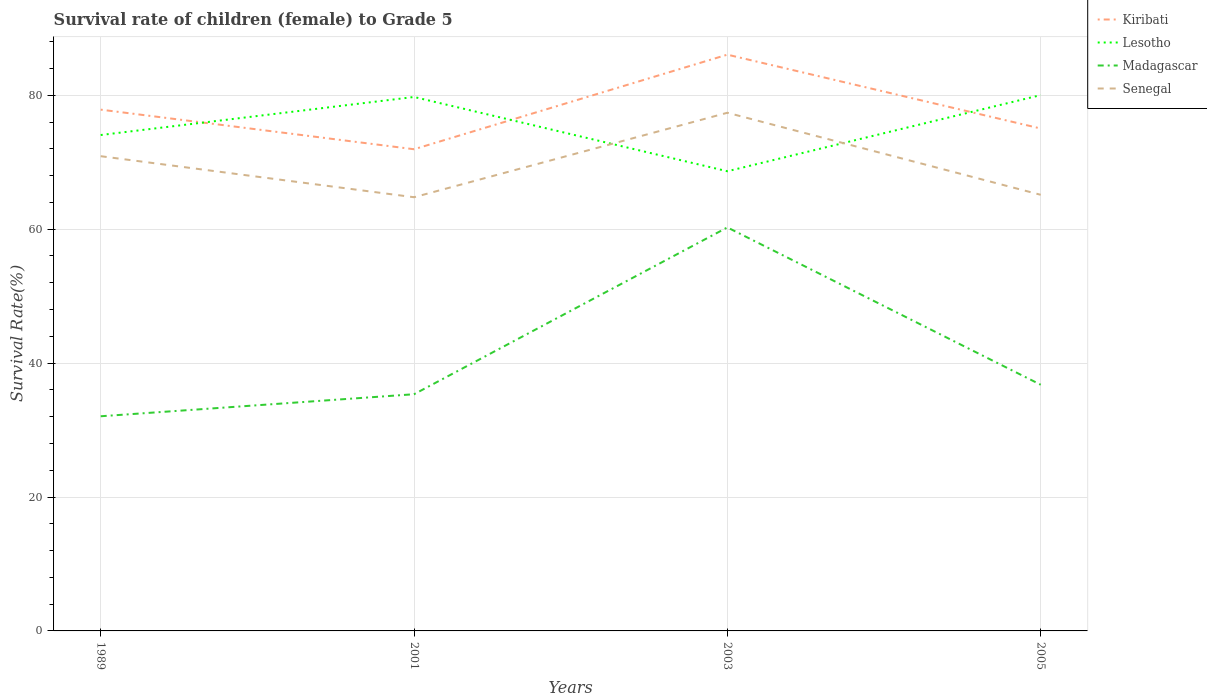Across all years, what is the maximum survival rate of female children to grade 5 in Kiribati?
Offer a very short reply. 71.94. What is the total survival rate of female children to grade 5 in Lesotho in the graph?
Your response must be concise. -0.28. What is the difference between the highest and the second highest survival rate of female children to grade 5 in Lesotho?
Ensure brevity in your answer.  11.37. How many years are there in the graph?
Provide a succinct answer. 4. What is the difference between two consecutive major ticks on the Y-axis?
Provide a short and direct response. 20. Are the values on the major ticks of Y-axis written in scientific E-notation?
Offer a terse response. No. Does the graph contain grids?
Provide a succinct answer. Yes. Where does the legend appear in the graph?
Offer a terse response. Top right. How many legend labels are there?
Your answer should be very brief. 4. What is the title of the graph?
Your response must be concise. Survival rate of children (female) to Grade 5. What is the label or title of the Y-axis?
Provide a short and direct response. Survival Rate(%). What is the Survival Rate(%) in Kiribati in 1989?
Provide a succinct answer. 77.85. What is the Survival Rate(%) of Lesotho in 1989?
Keep it short and to the point. 74.06. What is the Survival Rate(%) in Madagascar in 1989?
Your answer should be very brief. 32.06. What is the Survival Rate(%) of Senegal in 1989?
Offer a very short reply. 70.9. What is the Survival Rate(%) of Kiribati in 2001?
Provide a short and direct response. 71.94. What is the Survival Rate(%) of Lesotho in 2001?
Offer a very short reply. 79.74. What is the Survival Rate(%) of Madagascar in 2001?
Give a very brief answer. 35.35. What is the Survival Rate(%) of Senegal in 2001?
Ensure brevity in your answer.  64.77. What is the Survival Rate(%) of Kiribati in 2003?
Make the answer very short. 86.07. What is the Survival Rate(%) of Lesotho in 2003?
Your answer should be very brief. 68.65. What is the Survival Rate(%) in Madagascar in 2003?
Give a very brief answer. 60.26. What is the Survival Rate(%) in Senegal in 2003?
Provide a short and direct response. 77.39. What is the Survival Rate(%) of Kiribati in 2005?
Ensure brevity in your answer.  75.03. What is the Survival Rate(%) in Lesotho in 2005?
Give a very brief answer. 80.02. What is the Survival Rate(%) of Madagascar in 2005?
Your answer should be compact. 36.77. What is the Survival Rate(%) of Senegal in 2005?
Offer a very short reply. 65.13. Across all years, what is the maximum Survival Rate(%) of Kiribati?
Your answer should be compact. 86.07. Across all years, what is the maximum Survival Rate(%) of Lesotho?
Offer a very short reply. 80.02. Across all years, what is the maximum Survival Rate(%) of Madagascar?
Offer a terse response. 60.26. Across all years, what is the maximum Survival Rate(%) in Senegal?
Make the answer very short. 77.39. Across all years, what is the minimum Survival Rate(%) in Kiribati?
Your answer should be compact. 71.94. Across all years, what is the minimum Survival Rate(%) in Lesotho?
Ensure brevity in your answer.  68.65. Across all years, what is the minimum Survival Rate(%) of Madagascar?
Give a very brief answer. 32.06. Across all years, what is the minimum Survival Rate(%) in Senegal?
Your answer should be very brief. 64.77. What is the total Survival Rate(%) in Kiribati in the graph?
Your answer should be very brief. 310.89. What is the total Survival Rate(%) of Lesotho in the graph?
Make the answer very short. 302.48. What is the total Survival Rate(%) of Madagascar in the graph?
Ensure brevity in your answer.  164.44. What is the total Survival Rate(%) in Senegal in the graph?
Ensure brevity in your answer.  278.19. What is the difference between the Survival Rate(%) of Kiribati in 1989 and that in 2001?
Your answer should be compact. 5.91. What is the difference between the Survival Rate(%) of Lesotho in 1989 and that in 2001?
Make the answer very short. -5.68. What is the difference between the Survival Rate(%) of Madagascar in 1989 and that in 2001?
Offer a very short reply. -3.29. What is the difference between the Survival Rate(%) in Senegal in 1989 and that in 2001?
Your response must be concise. 6.13. What is the difference between the Survival Rate(%) in Kiribati in 1989 and that in 2003?
Your answer should be compact. -8.21. What is the difference between the Survival Rate(%) of Lesotho in 1989 and that in 2003?
Keep it short and to the point. 5.41. What is the difference between the Survival Rate(%) in Madagascar in 1989 and that in 2003?
Your answer should be compact. -28.2. What is the difference between the Survival Rate(%) in Senegal in 1989 and that in 2003?
Your answer should be compact. -6.49. What is the difference between the Survival Rate(%) of Kiribati in 1989 and that in 2005?
Offer a terse response. 2.82. What is the difference between the Survival Rate(%) of Lesotho in 1989 and that in 2005?
Give a very brief answer. -5.96. What is the difference between the Survival Rate(%) in Madagascar in 1989 and that in 2005?
Keep it short and to the point. -4.71. What is the difference between the Survival Rate(%) of Senegal in 1989 and that in 2005?
Ensure brevity in your answer.  5.77. What is the difference between the Survival Rate(%) in Kiribati in 2001 and that in 2003?
Ensure brevity in your answer.  -14.13. What is the difference between the Survival Rate(%) of Lesotho in 2001 and that in 2003?
Keep it short and to the point. 11.09. What is the difference between the Survival Rate(%) of Madagascar in 2001 and that in 2003?
Ensure brevity in your answer.  -24.91. What is the difference between the Survival Rate(%) in Senegal in 2001 and that in 2003?
Offer a terse response. -12.62. What is the difference between the Survival Rate(%) of Kiribati in 2001 and that in 2005?
Offer a terse response. -3.1. What is the difference between the Survival Rate(%) in Lesotho in 2001 and that in 2005?
Keep it short and to the point. -0.28. What is the difference between the Survival Rate(%) in Madagascar in 2001 and that in 2005?
Provide a short and direct response. -1.42. What is the difference between the Survival Rate(%) of Senegal in 2001 and that in 2005?
Your response must be concise. -0.36. What is the difference between the Survival Rate(%) of Kiribati in 2003 and that in 2005?
Ensure brevity in your answer.  11.03. What is the difference between the Survival Rate(%) in Lesotho in 2003 and that in 2005?
Make the answer very short. -11.37. What is the difference between the Survival Rate(%) in Madagascar in 2003 and that in 2005?
Keep it short and to the point. 23.5. What is the difference between the Survival Rate(%) in Senegal in 2003 and that in 2005?
Provide a short and direct response. 12.25. What is the difference between the Survival Rate(%) in Kiribati in 1989 and the Survival Rate(%) in Lesotho in 2001?
Your answer should be compact. -1.89. What is the difference between the Survival Rate(%) in Kiribati in 1989 and the Survival Rate(%) in Madagascar in 2001?
Provide a short and direct response. 42.5. What is the difference between the Survival Rate(%) in Kiribati in 1989 and the Survival Rate(%) in Senegal in 2001?
Give a very brief answer. 13.08. What is the difference between the Survival Rate(%) of Lesotho in 1989 and the Survival Rate(%) of Madagascar in 2001?
Provide a short and direct response. 38.71. What is the difference between the Survival Rate(%) of Lesotho in 1989 and the Survival Rate(%) of Senegal in 2001?
Offer a terse response. 9.29. What is the difference between the Survival Rate(%) in Madagascar in 1989 and the Survival Rate(%) in Senegal in 2001?
Your answer should be compact. -32.71. What is the difference between the Survival Rate(%) in Kiribati in 1989 and the Survival Rate(%) in Lesotho in 2003?
Your answer should be compact. 9.2. What is the difference between the Survival Rate(%) of Kiribati in 1989 and the Survival Rate(%) of Madagascar in 2003?
Your response must be concise. 17.59. What is the difference between the Survival Rate(%) of Kiribati in 1989 and the Survival Rate(%) of Senegal in 2003?
Offer a terse response. 0.46. What is the difference between the Survival Rate(%) of Lesotho in 1989 and the Survival Rate(%) of Madagascar in 2003?
Provide a succinct answer. 13.8. What is the difference between the Survival Rate(%) of Lesotho in 1989 and the Survival Rate(%) of Senegal in 2003?
Give a very brief answer. -3.33. What is the difference between the Survival Rate(%) in Madagascar in 1989 and the Survival Rate(%) in Senegal in 2003?
Provide a short and direct response. -45.33. What is the difference between the Survival Rate(%) in Kiribati in 1989 and the Survival Rate(%) in Lesotho in 2005?
Your answer should be very brief. -2.17. What is the difference between the Survival Rate(%) in Kiribati in 1989 and the Survival Rate(%) in Madagascar in 2005?
Make the answer very short. 41.09. What is the difference between the Survival Rate(%) of Kiribati in 1989 and the Survival Rate(%) of Senegal in 2005?
Provide a succinct answer. 12.72. What is the difference between the Survival Rate(%) in Lesotho in 1989 and the Survival Rate(%) in Madagascar in 2005?
Offer a terse response. 37.3. What is the difference between the Survival Rate(%) of Lesotho in 1989 and the Survival Rate(%) of Senegal in 2005?
Your answer should be compact. 8.93. What is the difference between the Survival Rate(%) of Madagascar in 1989 and the Survival Rate(%) of Senegal in 2005?
Keep it short and to the point. -33.07. What is the difference between the Survival Rate(%) in Kiribati in 2001 and the Survival Rate(%) in Lesotho in 2003?
Offer a very short reply. 3.29. What is the difference between the Survival Rate(%) of Kiribati in 2001 and the Survival Rate(%) of Madagascar in 2003?
Provide a succinct answer. 11.68. What is the difference between the Survival Rate(%) in Kiribati in 2001 and the Survival Rate(%) in Senegal in 2003?
Provide a succinct answer. -5.45. What is the difference between the Survival Rate(%) in Lesotho in 2001 and the Survival Rate(%) in Madagascar in 2003?
Offer a terse response. 19.48. What is the difference between the Survival Rate(%) in Lesotho in 2001 and the Survival Rate(%) in Senegal in 2003?
Your answer should be very brief. 2.36. What is the difference between the Survival Rate(%) in Madagascar in 2001 and the Survival Rate(%) in Senegal in 2003?
Your response must be concise. -42.04. What is the difference between the Survival Rate(%) of Kiribati in 2001 and the Survival Rate(%) of Lesotho in 2005?
Your answer should be compact. -8.08. What is the difference between the Survival Rate(%) of Kiribati in 2001 and the Survival Rate(%) of Madagascar in 2005?
Make the answer very short. 35.17. What is the difference between the Survival Rate(%) in Kiribati in 2001 and the Survival Rate(%) in Senegal in 2005?
Your response must be concise. 6.8. What is the difference between the Survival Rate(%) in Lesotho in 2001 and the Survival Rate(%) in Madagascar in 2005?
Give a very brief answer. 42.98. What is the difference between the Survival Rate(%) in Lesotho in 2001 and the Survival Rate(%) in Senegal in 2005?
Your answer should be very brief. 14.61. What is the difference between the Survival Rate(%) in Madagascar in 2001 and the Survival Rate(%) in Senegal in 2005?
Give a very brief answer. -29.79. What is the difference between the Survival Rate(%) in Kiribati in 2003 and the Survival Rate(%) in Lesotho in 2005?
Provide a succinct answer. 6.04. What is the difference between the Survival Rate(%) of Kiribati in 2003 and the Survival Rate(%) of Madagascar in 2005?
Ensure brevity in your answer.  49.3. What is the difference between the Survival Rate(%) of Kiribati in 2003 and the Survival Rate(%) of Senegal in 2005?
Ensure brevity in your answer.  20.93. What is the difference between the Survival Rate(%) of Lesotho in 2003 and the Survival Rate(%) of Madagascar in 2005?
Your answer should be compact. 31.89. What is the difference between the Survival Rate(%) of Lesotho in 2003 and the Survival Rate(%) of Senegal in 2005?
Give a very brief answer. 3.52. What is the difference between the Survival Rate(%) of Madagascar in 2003 and the Survival Rate(%) of Senegal in 2005?
Ensure brevity in your answer.  -4.87. What is the average Survival Rate(%) in Kiribati per year?
Provide a short and direct response. 77.72. What is the average Survival Rate(%) in Lesotho per year?
Ensure brevity in your answer.  75.62. What is the average Survival Rate(%) of Madagascar per year?
Your answer should be very brief. 41.11. What is the average Survival Rate(%) of Senegal per year?
Keep it short and to the point. 69.55. In the year 1989, what is the difference between the Survival Rate(%) of Kiribati and Survival Rate(%) of Lesotho?
Give a very brief answer. 3.79. In the year 1989, what is the difference between the Survival Rate(%) in Kiribati and Survival Rate(%) in Madagascar?
Your response must be concise. 45.79. In the year 1989, what is the difference between the Survival Rate(%) in Kiribati and Survival Rate(%) in Senegal?
Keep it short and to the point. 6.95. In the year 1989, what is the difference between the Survival Rate(%) in Lesotho and Survival Rate(%) in Madagascar?
Ensure brevity in your answer.  42. In the year 1989, what is the difference between the Survival Rate(%) of Lesotho and Survival Rate(%) of Senegal?
Provide a succinct answer. 3.16. In the year 1989, what is the difference between the Survival Rate(%) of Madagascar and Survival Rate(%) of Senegal?
Provide a succinct answer. -38.84. In the year 2001, what is the difference between the Survival Rate(%) of Kiribati and Survival Rate(%) of Lesotho?
Your response must be concise. -7.8. In the year 2001, what is the difference between the Survival Rate(%) of Kiribati and Survival Rate(%) of Madagascar?
Provide a short and direct response. 36.59. In the year 2001, what is the difference between the Survival Rate(%) in Kiribati and Survival Rate(%) in Senegal?
Give a very brief answer. 7.17. In the year 2001, what is the difference between the Survival Rate(%) in Lesotho and Survival Rate(%) in Madagascar?
Provide a short and direct response. 44.39. In the year 2001, what is the difference between the Survival Rate(%) in Lesotho and Survival Rate(%) in Senegal?
Make the answer very short. 14.97. In the year 2001, what is the difference between the Survival Rate(%) of Madagascar and Survival Rate(%) of Senegal?
Provide a succinct answer. -29.42. In the year 2003, what is the difference between the Survival Rate(%) of Kiribati and Survival Rate(%) of Lesotho?
Provide a succinct answer. 17.41. In the year 2003, what is the difference between the Survival Rate(%) in Kiribati and Survival Rate(%) in Madagascar?
Give a very brief answer. 25.8. In the year 2003, what is the difference between the Survival Rate(%) in Kiribati and Survival Rate(%) in Senegal?
Your response must be concise. 8.68. In the year 2003, what is the difference between the Survival Rate(%) in Lesotho and Survival Rate(%) in Madagascar?
Provide a short and direct response. 8.39. In the year 2003, what is the difference between the Survival Rate(%) of Lesotho and Survival Rate(%) of Senegal?
Offer a terse response. -8.74. In the year 2003, what is the difference between the Survival Rate(%) of Madagascar and Survival Rate(%) of Senegal?
Provide a short and direct response. -17.12. In the year 2005, what is the difference between the Survival Rate(%) of Kiribati and Survival Rate(%) of Lesotho?
Offer a terse response. -4.99. In the year 2005, what is the difference between the Survival Rate(%) of Kiribati and Survival Rate(%) of Madagascar?
Keep it short and to the point. 38.27. In the year 2005, what is the difference between the Survival Rate(%) in Kiribati and Survival Rate(%) in Senegal?
Provide a short and direct response. 9.9. In the year 2005, what is the difference between the Survival Rate(%) in Lesotho and Survival Rate(%) in Madagascar?
Your answer should be compact. 43.26. In the year 2005, what is the difference between the Survival Rate(%) in Lesotho and Survival Rate(%) in Senegal?
Provide a succinct answer. 14.89. In the year 2005, what is the difference between the Survival Rate(%) in Madagascar and Survival Rate(%) in Senegal?
Your response must be concise. -28.37. What is the ratio of the Survival Rate(%) of Kiribati in 1989 to that in 2001?
Provide a succinct answer. 1.08. What is the ratio of the Survival Rate(%) of Lesotho in 1989 to that in 2001?
Offer a very short reply. 0.93. What is the ratio of the Survival Rate(%) of Madagascar in 1989 to that in 2001?
Give a very brief answer. 0.91. What is the ratio of the Survival Rate(%) of Senegal in 1989 to that in 2001?
Offer a terse response. 1.09. What is the ratio of the Survival Rate(%) in Kiribati in 1989 to that in 2003?
Make the answer very short. 0.9. What is the ratio of the Survival Rate(%) of Lesotho in 1989 to that in 2003?
Provide a succinct answer. 1.08. What is the ratio of the Survival Rate(%) of Madagascar in 1989 to that in 2003?
Your answer should be very brief. 0.53. What is the ratio of the Survival Rate(%) of Senegal in 1989 to that in 2003?
Provide a short and direct response. 0.92. What is the ratio of the Survival Rate(%) of Kiribati in 1989 to that in 2005?
Provide a succinct answer. 1.04. What is the ratio of the Survival Rate(%) of Lesotho in 1989 to that in 2005?
Ensure brevity in your answer.  0.93. What is the ratio of the Survival Rate(%) of Madagascar in 1989 to that in 2005?
Offer a very short reply. 0.87. What is the ratio of the Survival Rate(%) of Senegal in 1989 to that in 2005?
Your answer should be compact. 1.09. What is the ratio of the Survival Rate(%) of Kiribati in 2001 to that in 2003?
Your response must be concise. 0.84. What is the ratio of the Survival Rate(%) in Lesotho in 2001 to that in 2003?
Offer a terse response. 1.16. What is the ratio of the Survival Rate(%) of Madagascar in 2001 to that in 2003?
Give a very brief answer. 0.59. What is the ratio of the Survival Rate(%) in Senegal in 2001 to that in 2003?
Keep it short and to the point. 0.84. What is the ratio of the Survival Rate(%) in Kiribati in 2001 to that in 2005?
Offer a terse response. 0.96. What is the ratio of the Survival Rate(%) of Madagascar in 2001 to that in 2005?
Provide a short and direct response. 0.96. What is the ratio of the Survival Rate(%) in Senegal in 2001 to that in 2005?
Ensure brevity in your answer.  0.99. What is the ratio of the Survival Rate(%) in Kiribati in 2003 to that in 2005?
Provide a succinct answer. 1.15. What is the ratio of the Survival Rate(%) in Lesotho in 2003 to that in 2005?
Provide a short and direct response. 0.86. What is the ratio of the Survival Rate(%) in Madagascar in 2003 to that in 2005?
Give a very brief answer. 1.64. What is the ratio of the Survival Rate(%) of Senegal in 2003 to that in 2005?
Your response must be concise. 1.19. What is the difference between the highest and the second highest Survival Rate(%) in Kiribati?
Keep it short and to the point. 8.21. What is the difference between the highest and the second highest Survival Rate(%) of Lesotho?
Offer a terse response. 0.28. What is the difference between the highest and the second highest Survival Rate(%) in Madagascar?
Ensure brevity in your answer.  23.5. What is the difference between the highest and the second highest Survival Rate(%) of Senegal?
Offer a terse response. 6.49. What is the difference between the highest and the lowest Survival Rate(%) in Kiribati?
Offer a terse response. 14.13. What is the difference between the highest and the lowest Survival Rate(%) of Lesotho?
Offer a terse response. 11.37. What is the difference between the highest and the lowest Survival Rate(%) in Madagascar?
Give a very brief answer. 28.2. What is the difference between the highest and the lowest Survival Rate(%) in Senegal?
Give a very brief answer. 12.62. 